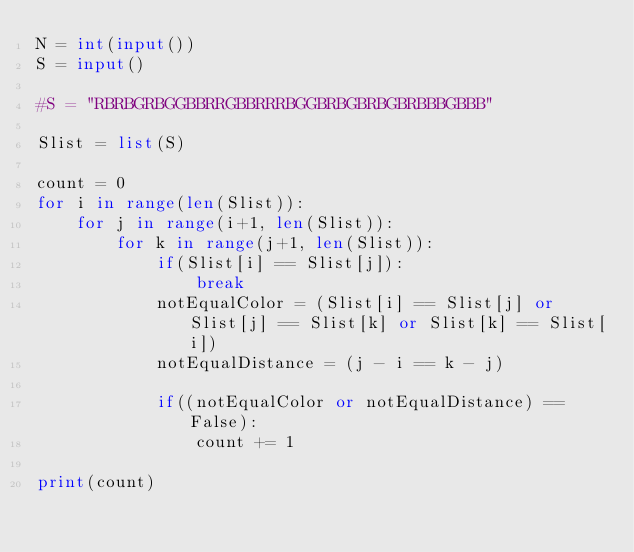<code> <loc_0><loc_0><loc_500><loc_500><_Python_>N = int(input())
S = input()

#S = "RBRBGRBGGBBRRGBBRRRBGGBRBGBRBGBRBBBGBBB"

Slist = list(S)

count = 0
for i in range(len(Slist)):
    for j in range(i+1, len(Slist)):
        for k in range(j+1, len(Slist)):
            if(Slist[i] == Slist[j]):
                break
            notEqualColor = (Slist[i] == Slist[j] or Slist[j] == Slist[k] or Slist[k] == Slist[i])
            notEqualDistance = (j - i == k - j)

            if((notEqualColor or notEqualDistance) == False):
                count += 1

print(count)
</code> 